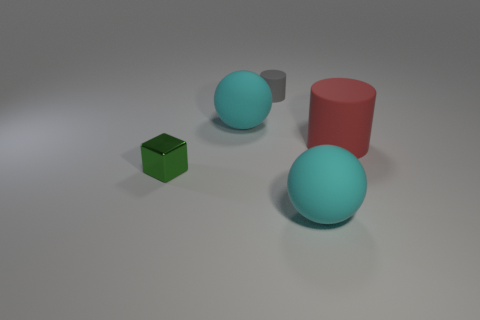Add 2 matte spheres. How many objects exist? 7 Subtract all cylinders. How many objects are left? 3 Subtract 0 cyan cubes. How many objects are left? 5 Subtract all cyan rubber balls. Subtract all large matte cylinders. How many objects are left? 2 Add 4 blocks. How many blocks are left? 5 Add 4 big red matte cylinders. How many big red matte cylinders exist? 5 